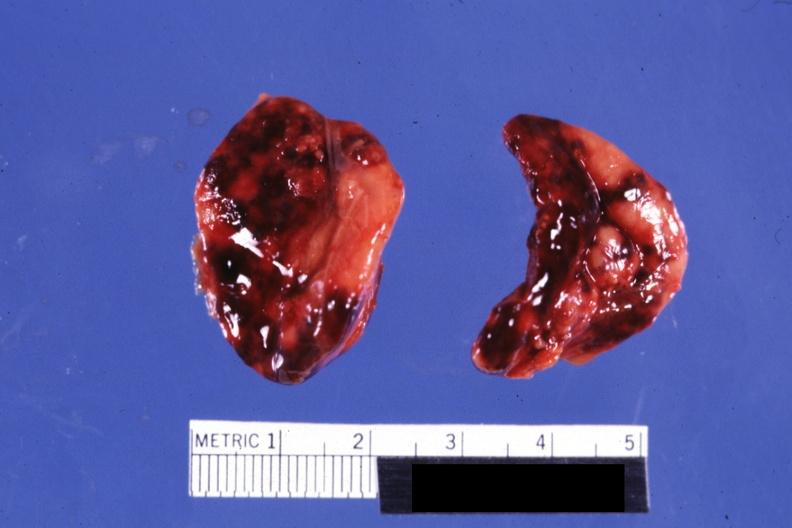s endocrine present?
Answer the question using a single word or phrase. Yes 